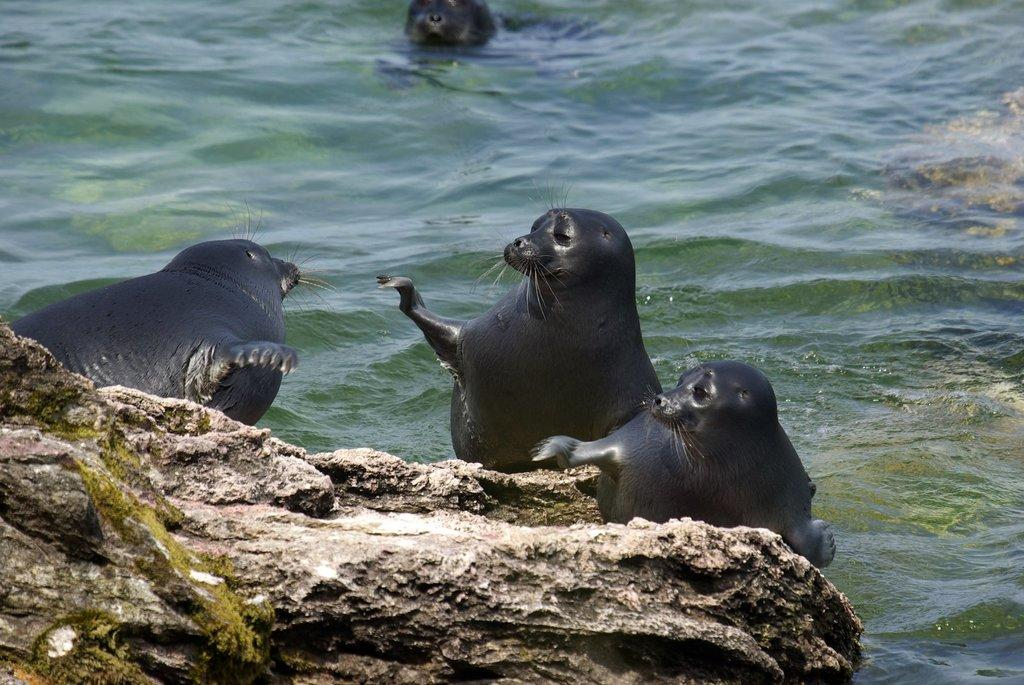What is the main object in the image? There is a rock in the image. What animals can be seen behind the rock? There are seals behind the rock. What type of environment is depicted in the image? The image shows a water surface, which suggests a coastal or aquatic setting. What type of brush can be seen in the image? There is no brush present in the image. How do the seals move around in the image? The seals are not shown moving in the image; they are stationary behind the rock. 